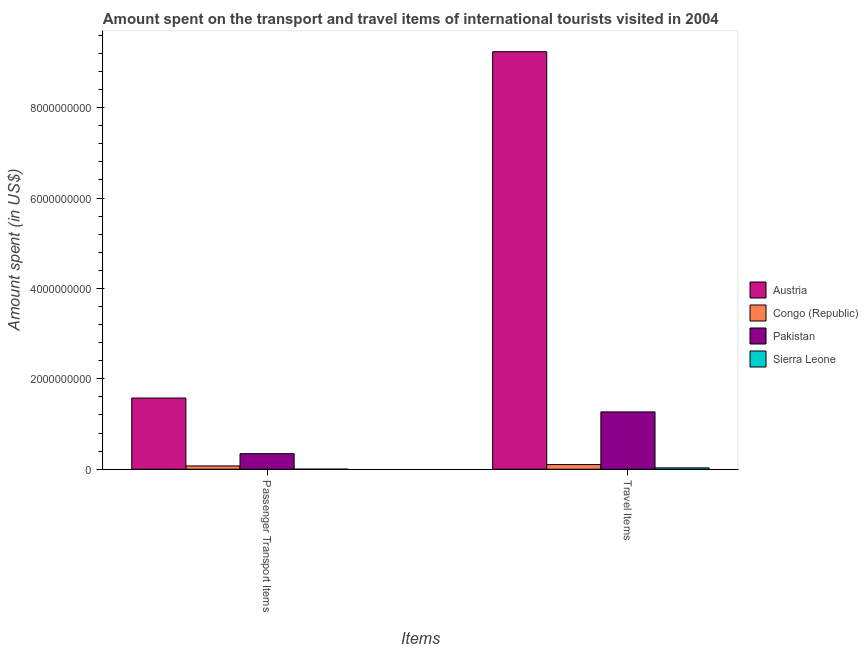Are the number of bars on each tick of the X-axis equal?
Offer a terse response. Yes. What is the label of the 2nd group of bars from the left?
Provide a succinct answer. Travel Items. What is the amount spent in travel items in Pakistan?
Offer a very short reply. 1.27e+09. Across all countries, what is the maximum amount spent in travel items?
Make the answer very short. 9.24e+09. Across all countries, what is the minimum amount spent on passenger transport items?
Your answer should be very brief. 3.00e+05. In which country was the amount spent on passenger transport items maximum?
Provide a succinct answer. Austria. In which country was the amount spent in travel items minimum?
Make the answer very short. Sierra Leone. What is the total amount spent in travel items in the graph?
Your answer should be compact. 1.06e+1. What is the difference between the amount spent on passenger transport items in Pakistan and that in Austria?
Ensure brevity in your answer.  -1.23e+09. What is the difference between the amount spent in travel items in Congo (Republic) and the amount spent on passenger transport items in Sierra Leone?
Your answer should be compact. 1.03e+08. What is the average amount spent on passenger transport items per country?
Make the answer very short. 4.98e+08. What is the difference between the amount spent in travel items and amount spent on passenger transport items in Pakistan?
Ensure brevity in your answer.  9.24e+08. In how many countries, is the amount spent in travel items greater than 400000000 US$?
Your answer should be very brief. 2. What is the ratio of the amount spent in travel items in Pakistan to that in Sierra Leone?
Offer a very short reply. 42.27. Is the amount spent in travel items in Sierra Leone less than that in Austria?
Your response must be concise. Yes. What does the 2nd bar from the left in Travel Items represents?
Provide a succinct answer. Congo (Republic). Are all the bars in the graph horizontal?
Offer a terse response. No. How many countries are there in the graph?
Provide a succinct answer. 4. What is the difference between two consecutive major ticks on the Y-axis?
Give a very brief answer. 2.00e+09. Are the values on the major ticks of Y-axis written in scientific E-notation?
Your response must be concise. No. Does the graph contain any zero values?
Ensure brevity in your answer.  No. Does the graph contain grids?
Give a very brief answer. No. How are the legend labels stacked?
Ensure brevity in your answer.  Vertical. What is the title of the graph?
Make the answer very short. Amount spent on the transport and travel items of international tourists visited in 2004. What is the label or title of the X-axis?
Offer a terse response. Items. What is the label or title of the Y-axis?
Offer a very short reply. Amount spent (in US$). What is the Amount spent (in US$) in Austria in Passenger Transport Items?
Ensure brevity in your answer.  1.58e+09. What is the Amount spent (in US$) in Congo (Republic) in Passenger Transport Items?
Your answer should be very brief. 7.30e+07. What is the Amount spent (in US$) of Pakistan in Passenger Transport Items?
Provide a short and direct response. 3.44e+08. What is the Amount spent (in US$) in Austria in Travel Items?
Offer a terse response. 9.24e+09. What is the Amount spent (in US$) of Congo (Republic) in Travel Items?
Provide a short and direct response. 1.03e+08. What is the Amount spent (in US$) in Pakistan in Travel Items?
Offer a terse response. 1.27e+09. What is the Amount spent (in US$) in Sierra Leone in Travel Items?
Keep it short and to the point. 3.00e+07. Across all Items, what is the maximum Amount spent (in US$) in Austria?
Your answer should be compact. 9.24e+09. Across all Items, what is the maximum Amount spent (in US$) of Congo (Republic)?
Offer a terse response. 1.03e+08. Across all Items, what is the maximum Amount spent (in US$) in Pakistan?
Offer a terse response. 1.27e+09. Across all Items, what is the maximum Amount spent (in US$) of Sierra Leone?
Your answer should be very brief. 3.00e+07. Across all Items, what is the minimum Amount spent (in US$) of Austria?
Provide a succinct answer. 1.58e+09. Across all Items, what is the minimum Amount spent (in US$) of Congo (Republic)?
Offer a very short reply. 7.30e+07. Across all Items, what is the minimum Amount spent (in US$) in Pakistan?
Give a very brief answer. 3.44e+08. Across all Items, what is the minimum Amount spent (in US$) in Sierra Leone?
Make the answer very short. 3.00e+05. What is the total Amount spent (in US$) in Austria in the graph?
Ensure brevity in your answer.  1.08e+1. What is the total Amount spent (in US$) of Congo (Republic) in the graph?
Offer a very short reply. 1.76e+08. What is the total Amount spent (in US$) of Pakistan in the graph?
Offer a very short reply. 1.61e+09. What is the total Amount spent (in US$) in Sierra Leone in the graph?
Keep it short and to the point. 3.03e+07. What is the difference between the Amount spent (in US$) of Austria in Passenger Transport Items and that in Travel Items?
Offer a very short reply. -7.66e+09. What is the difference between the Amount spent (in US$) in Congo (Republic) in Passenger Transport Items and that in Travel Items?
Make the answer very short. -3.00e+07. What is the difference between the Amount spent (in US$) in Pakistan in Passenger Transport Items and that in Travel Items?
Your response must be concise. -9.24e+08. What is the difference between the Amount spent (in US$) of Sierra Leone in Passenger Transport Items and that in Travel Items?
Keep it short and to the point. -2.97e+07. What is the difference between the Amount spent (in US$) in Austria in Passenger Transport Items and the Amount spent (in US$) in Congo (Republic) in Travel Items?
Your answer should be compact. 1.47e+09. What is the difference between the Amount spent (in US$) of Austria in Passenger Transport Items and the Amount spent (in US$) of Pakistan in Travel Items?
Make the answer very short. 3.07e+08. What is the difference between the Amount spent (in US$) in Austria in Passenger Transport Items and the Amount spent (in US$) in Sierra Leone in Travel Items?
Provide a short and direct response. 1.54e+09. What is the difference between the Amount spent (in US$) in Congo (Republic) in Passenger Transport Items and the Amount spent (in US$) in Pakistan in Travel Items?
Your answer should be very brief. -1.20e+09. What is the difference between the Amount spent (in US$) in Congo (Republic) in Passenger Transport Items and the Amount spent (in US$) in Sierra Leone in Travel Items?
Make the answer very short. 4.30e+07. What is the difference between the Amount spent (in US$) of Pakistan in Passenger Transport Items and the Amount spent (in US$) of Sierra Leone in Travel Items?
Your answer should be compact. 3.14e+08. What is the average Amount spent (in US$) in Austria per Items?
Provide a short and direct response. 5.41e+09. What is the average Amount spent (in US$) in Congo (Republic) per Items?
Your response must be concise. 8.80e+07. What is the average Amount spent (in US$) in Pakistan per Items?
Your answer should be compact. 8.06e+08. What is the average Amount spent (in US$) of Sierra Leone per Items?
Make the answer very short. 1.52e+07. What is the difference between the Amount spent (in US$) of Austria and Amount spent (in US$) of Congo (Republic) in Passenger Transport Items?
Offer a terse response. 1.50e+09. What is the difference between the Amount spent (in US$) of Austria and Amount spent (in US$) of Pakistan in Passenger Transport Items?
Ensure brevity in your answer.  1.23e+09. What is the difference between the Amount spent (in US$) in Austria and Amount spent (in US$) in Sierra Leone in Passenger Transport Items?
Make the answer very short. 1.57e+09. What is the difference between the Amount spent (in US$) of Congo (Republic) and Amount spent (in US$) of Pakistan in Passenger Transport Items?
Make the answer very short. -2.71e+08. What is the difference between the Amount spent (in US$) in Congo (Republic) and Amount spent (in US$) in Sierra Leone in Passenger Transport Items?
Your response must be concise. 7.27e+07. What is the difference between the Amount spent (in US$) in Pakistan and Amount spent (in US$) in Sierra Leone in Passenger Transport Items?
Provide a succinct answer. 3.44e+08. What is the difference between the Amount spent (in US$) of Austria and Amount spent (in US$) of Congo (Republic) in Travel Items?
Provide a succinct answer. 9.13e+09. What is the difference between the Amount spent (in US$) of Austria and Amount spent (in US$) of Pakistan in Travel Items?
Make the answer very short. 7.97e+09. What is the difference between the Amount spent (in US$) of Austria and Amount spent (in US$) of Sierra Leone in Travel Items?
Your answer should be compact. 9.21e+09. What is the difference between the Amount spent (in US$) in Congo (Republic) and Amount spent (in US$) in Pakistan in Travel Items?
Offer a very short reply. -1.16e+09. What is the difference between the Amount spent (in US$) in Congo (Republic) and Amount spent (in US$) in Sierra Leone in Travel Items?
Offer a terse response. 7.30e+07. What is the difference between the Amount spent (in US$) in Pakistan and Amount spent (in US$) in Sierra Leone in Travel Items?
Offer a very short reply. 1.24e+09. What is the ratio of the Amount spent (in US$) of Austria in Passenger Transport Items to that in Travel Items?
Offer a terse response. 0.17. What is the ratio of the Amount spent (in US$) of Congo (Republic) in Passenger Transport Items to that in Travel Items?
Your answer should be compact. 0.71. What is the ratio of the Amount spent (in US$) of Pakistan in Passenger Transport Items to that in Travel Items?
Offer a terse response. 0.27. What is the difference between the highest and the second highest Amount spent (in US$) of Austria?
Your answer should be compact. 7.66e+09. What is the difference between the highest and the second highest Amount spent (in US$) of Congo (Republic)?
Keep it short and to the point. 3.00e+07. What is the difference between the highest and the second highest Amount spent (in US$) of Pakistan?
Provide a short and direct response. 9.24e+08. What is the difference between the highest and the second highest Amount spent (in US$) in Sierra Leone?
Offer a terse response. 2.97e+07. What is the difference between the highest and the lowest Amount spent (in US$) in Austria?
Your answer should be very brief. 7.66e+09. What is the difference between the highest and the lowest Amount spent (in US$) of Congo (Republic)?
Ensure brevity in your answer.  3.00e+07. What is the difference between the highest and the lowest Amount spent (in US$) of Pakistan?
Ensure brevity in your answer.  9.24e+08. What is the difference between the highest and the lowest Amount spent (in US$) in Sierra Leone?
Your answer should be compact. 2.97e+07. 